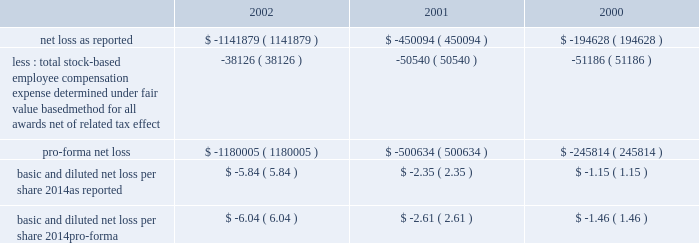American tower corporation and subsidiaries notes to consolidated financial statements 2014 ( continued ) the table illustrates the effect on net loss and net loss per share if the company had applied the fair value recognition provisions of sfas no .
123 to stock-based compensation .
The estimated fair value of each option is calculated using the black-scholes option-pricing model ( in thousands , except per share amounts ) : .
Fair value of financial instruments 2014as of december 31 , 2002 , the carrying amounts of the company 2019s 5.0% ( 5.0 % ) convertible notes , the 2.25% ( 2.25 % ) convertible notes , the 6.25% ( 6.25 % ) convertible notes and the senior notes were approximately $ 450.0 million , $ 210.9 million , $ 212.7 million and $ 1.0 billion , respectively , and the fair values of such notes were $ 291.4 million , $ 187.2 million , $ 144.4 million and $ 780.0 million , respectively .
As of december 31 , 2001 , the carrying amount of the company 2019s 5.0% ( 5.0 % ) convertible notes , the 2.25% ( 2.25 % ) convertible notes , the 6.25% ( 6.25 % ) convertible notes and the senior notes were approximately $ 450.0 million , $ 204.1 million , $ 212.8 million and $ 1.0 billion , respectively , and the fair values of such notes were $ 268.3 million , $ 173.1 million , $ 158.2 million and $ 805.0 million , respectively .
Fair values were determined based on quoted market prices .
The carrying values of all other financial instruments reasonably approximate the related fair values as of december 31 , 2002 and 2001 .
Retirement plan 2014the company has a 401 ( k ) plan covering substantially all employees who meet certain age and employment requirements .
Under the plan , the company matches 35% ( 35 % ) of participants 2019 contributions up to a maximum 5% ( 5 % ) of a participant 2019s compensation .
The company contributed approximately $ 979000 , $ 1540000 and $ 1593000 to the plan for the years ended december 31 , 2002 , 2001 and 2000 , respectively .
Recent accounting pronouncements 2014in june 2001 , the fasb issued sfas no .
143 , 201caccounting for asset retirement obligations . 201d this statement establishes accounting standards for the recognition and measurement of liabilities associated with the retirement of tangible long-lived assets and the related asset retirement costs .
The requirements of sfas no .
143 are effective for the company as of january 1 , 2003 .
The company will adopt this statement in the first quarter of 2003 and does not expect the impact of adopting this statement to have a material impact on its consolidated financial position or results of operations .
In august 2001 , the fasb issued sfas no .
144 , 201caccounting for the impairment or disposal of long-lived assets . 201d sfas no .
144 supersedes sfas no .
121 , 201caccounting for the impairment of long-lived assets and for long-lived assets to be disposed of , 201d but retains many of its fundamental provisions .
Sfas no .
144 also clarifies certain measurement and classification issues from sfas no .
121 .
In addition , sfas no .
144 supersedes the accounting and reporting provisions for the disposal of a business segment as found in apb no .
30 , 201creporting the results of operations 2014reporting the effects of disposal of a segment of a business and extraordinary , unusual and infrequently occurring events and transactions 201d .
However , sfas no .
144 retains the requirement in apb no .
30 to separately report discontinued operations , and broadens the scope of such requirement to include more types of disposal transactions .
The scope of sfas no .
144 excludes goodwill and other intangible assets that are not to be amortized , as the accounting for such items is prescribed by sfas no .
142 .
The company implemented sfas no .
144 on january 1 , 2002 .
Accordingly , all relevant impairment assessments and decisions concerning discontinued operations have been made under this standard in 2002. .
What is the percentage change in 401 ( k ) contributions from 2001 to 2002? 
Computations: ((979000 - 1540000) / 1540000)
Answer: -0.36429. American tower corporation and subsidiaries notes to consolidated financial statements 2014 ( continued ) the table illustrates the effect on net loss and net loss per share if the company had applied the fair value recognition provisions of sfas no .
123 to stock-based compensation .
The estimated fair value of each option is calculated using the black-scholes option-pricing model ( in thousands , except per share amounts ) : .
Fair value of financial instruments 2014as of december 31 , 2002 , the carrying amounts of the company 2019s 5.0% ( 5.0 % ) convertible notes , the 2.25% ( 2.25 % ) convertible notes , the 6.25% ( 6.25 % ) convertible notes and the senior notes were approximately $ 450.0 million , $ 210.9 million , $ 212.7 million and $ 1.0 billion , respectively , and the fair values of such notes were $ 291.4 million , $ 187.2 million , $ 144.4 million and $ 780.0 million , respectively .
As of december 31 , 2001 , the carrying amount of the company 2019s 5.0% ( 5.0 % ) convertible notes , the 2.25% ( 2.25 % ) convertible notes , the 6.25% ( 6.25 % ) convertible notes and the senior notes were approximately $ 450.0 million , $ 204.1 million , $ 212.8 million and $ 1.0 billion , respectively , and the fair values of such notes were $ 268.3 million , $ 173.1 million , $ 158.2 million and $ 805.0 million , respectively .
Fair values were determined based on quoted market prices .
The carrying values of all other financial instruments reasonably approximate the related fair values as of december 31 , 2002 and 2001 .
Retirement plan 2014the company has a 401 ( k ) plan covering substantially all employees who meet certain age and employment requirements .
Under the plan , the company matches 35% ( 35 % ) of participants 2019 contributions up to a maximum 5% ( 5 % ) of a participant 2019s compensation .
The company contributed approximately $ 979000 , $ 1540000 and $ 1593000 to the plan for the years ended december 31 , 2002 , 2001 and 2000 , respectively .
Recent accounting pronouncements 2014in june 2001 , the fasb issued sfas no .
143 , 201caccounting for asset retirement obligations . 201d this statement establishes accounting standards for the recognition and measurement of liabilities associated with the retirement of tangible long-lived assets and the related asset retirement costs .
The requirements of sfas no .
143 are effective for the company as of january 1 , 2003 .
The company will adopt this statement in the first quarter of 2003 and does not expect the impact of adopting this statement to have a material impact on its consolidated financial position or results of operations .
In august 2001 , the fasb issued sfas no .
144 , 201caccounting for the impairment or disposal of long-lived assets . 201d sfas no .
144 supersedes sfas no .
121 , 201caccounting for the impairment of long-lived assets and for long-lived assets to be disposed of , 201d but retains many of its fundamental provisions .
Sfas no .
144 also clarifies certain measurement and classification issues from sfas no .
121 .
In addition , sfas no .
144 supersedes the accounting and reporting provisions for the disposal of a business segment as found in apb no .
30 , 201creporting the results of operations 2014reporting the effects of disposal of a segment of a business and extraordinary , unusual and infrequently occurring events and transactions 201d .
However , sfas no .
144 retains the requirement in apb no .
30 to separately report discontinued operations , and broadens the scope of such requirement to include more types of disposal transactions .
The scope of sfas no .
144 excludes goodwill and other intangible assets that are not to be amortized , as the accounting for such items is prescribed by sfas no .
142 .
The company implemented sfas no .
144 on january 1 , 2002 .
Accordingly , all relevant impairment assessments and decisions concerning discontinued operations have been made under this standard in 2002. .
Based on the black-scholes option-pricing model what was the percentage change in the net loss as reported from 2001 to 2002? 
Computations: ((1141879 - 450094) / 450094)
Answer: 1.53698. 